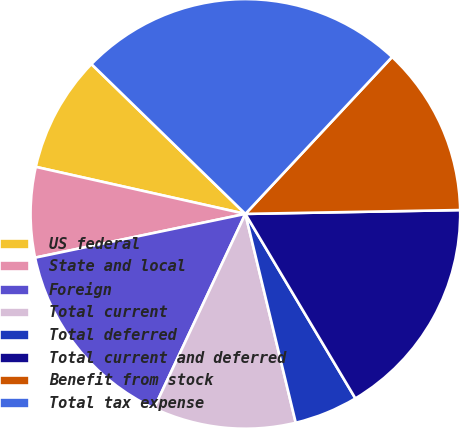<chart> <loc_0><loc_0><loc_500><loc_500><pie_chart><fcel>US federal<fcel>State and local<fcel>Foreign<fcel>Total current<fcel>Total deferred<fcel>Total current and deferred<fcel>Benefit from stock<fcel>Total tax expense<nl><fcel>8.77%<fcel>6.78%<fcel>14.74%<fcel>10.76%<fcel>4.79%<fcel>16.73%<fcel>12.75%<fcel>24.68%<nl></chart> 